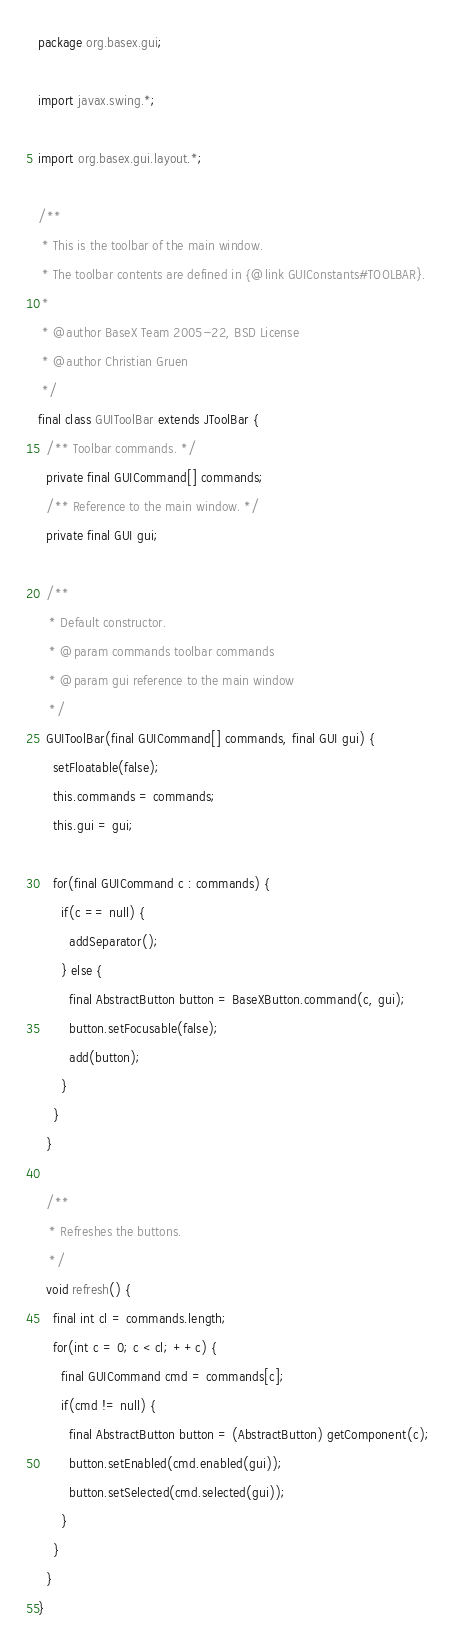<code> <loc_0><loc_0><loc_500><loc_500><_Java_>package org.basex.gui;

import javax.swing.*;

import org.basex.gui.layout.*;

/**
 * This is the toolbar of the main window.
 * The toolbar contents are defined in {@link GUIConstants#TOOLBAR}.
 *
 * @author BaseX Team 2005-22, BSD License
 * @author Christian Gruen
 */
final class GUIToolBar extends JToolBar {
  /** Toolbar commands. */
  private final GUICommand[] commands;
  /** Reference to the main window. */
  private final GUI gui;

  /**
   * Default constructor.
   * @param commands toolbar commands
   * @param gui reference to the main window
   */
  GUIToolBar(final GUICommand[] commands, final GUI gui) {
    setFloatable(false);
    this.commands = commands;
    this.gui = gui;

    for(final GUICommand c : commands) {
      if(c == null) {
        addSeparator();
      } else {
        final AbstractButton button = BaseXButton.command(c, gui);
        button.setFocusable(false);
        add(button);
      }
    }
  }

  /**
   * Refreshes the buttons.
   */
  void refresh() {
    final int cl = commands.length;
    for(int c = 0; c < cl; ++c) {
      final GUICommand cmd = commands[c];
      if(cmd != null) {
        final AbstractButton button = (AbstractButton) getComponent(c);
        button.setEnabled(cmd.enabled(gui));
        button.setSelected(cmd.selected(gui));
      }
    }
  }
}
</code> 